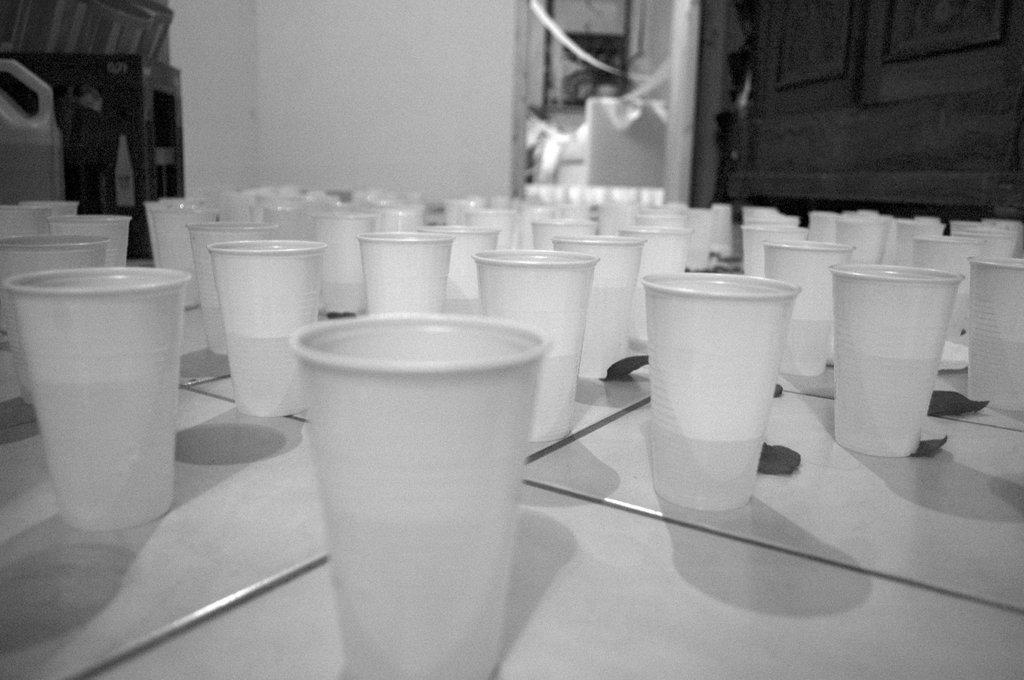What objects are on the floor in the image? There are glasses on the floor in the image. What is located at the top of the image? There is a wall at the top of the image. Where is the table positioned in the image? There is a table in the top left of the image. How many women are guiding the sack through the image? There are no women or sacks present in the image. 